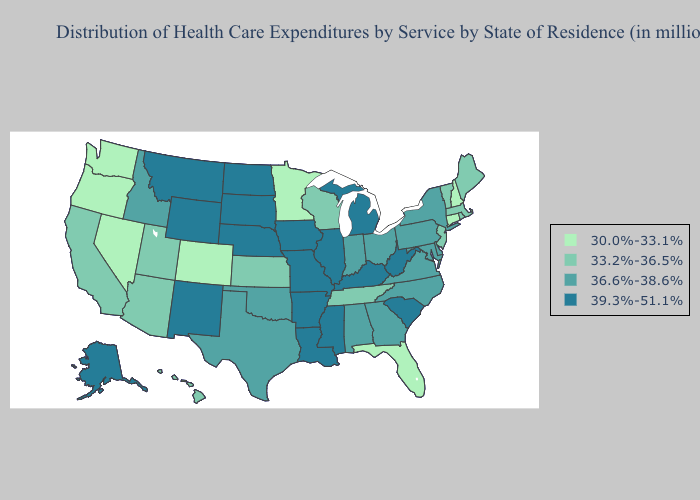Is the legend a continuous bar?
Short answer required. No. Does Iowa have a higher value than South Carolina?
Answer briefly. No. What is the lowest value in states that border Louisiana?
Give a very brief answer. 36.6%-38.6%. Does Delaware have the highest value in the South?
Keep it brief. No. What is the value of Arkansas?
Answer briefly. 39.3%-51.1%. What is the highest value in states that border Arizona?
Keep it brief. 39.3%-51.1%. Does Rhode Island have a higher value than Georgia?
Write a very short answer. No. Which states have the lowest value in the USA?
Answer briefly. Colorado, Connecticut, Florida, Minnesota, Nevada, New Hampshire, Oregon, Washington. How many symbols are there in the legend?
Concise answer only. 4. Does California have the lowest value in the USA?
Give a very brief answer. No. Among the states that border Kentucky , does Tennessee have the lowest value?
Write a very short answer. Yes. Name the states that have a value in the range 33.2%-36.5%?
Keep it brief. Arizona, California, Hawaii, Kansas, Maine, Massachusetts, New Jersey, Rhode Island, Tennessee, Utah, Vermont, Wisconsin. What is the value of Montana?
Quick response, please. 39.3%-51.1%. Among the states that border North Dakota , does South Dakota have the highest value?
Answer briefly. Yes. Name the states that have a value in the range 30.0%-33.1%?
Give a very brief answer. Colorado, Connecticut, Florida, Minnesota, Nevada, New Hampshire, Oregon, Washington. 